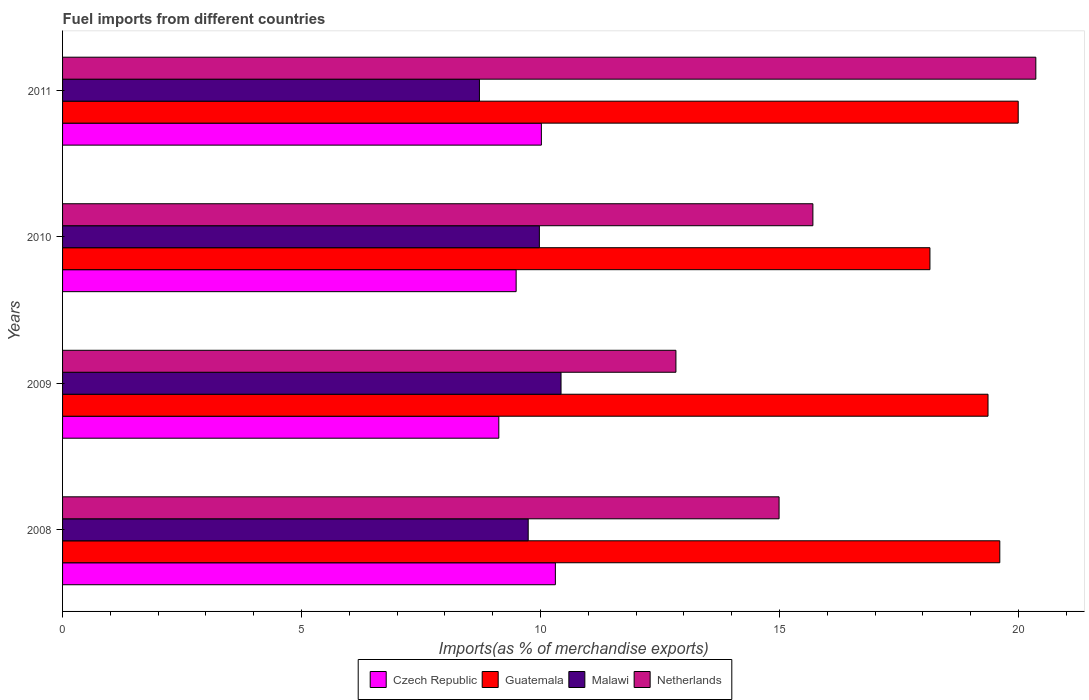How many different coloured bars are there?
Make the answer very short. 4. How many groups of bars are there?
Offer a very short reply. 4. Are the number of bars on each tick of the Y-axis equal?
Make the answer very short. Yes. How many bars are there on the 3rd tick from the bottom?
Provide a succinct answer. 4. In how many cases, is the number of bars for a given year not equal to the number of legend labels?
Your answer should be very brief. 0. What is the percentage of imports to different countries in Guatemala in 2011?
Your answer should be very brief. 19.99. Across all years, what is the maximum percentage of imports to different countries in Netherlands?
Your answer should be very brief. 20.36. Across all years, what is the minimum percentage of imports to different countries in Netherlands?
Give a very brief answer. 12.83. In which year was the percentage of imports to different countries in Netherlands maximum?
Provide a short and direct response. 2011. In which year was the percentage of imports to different countries in Czech Republic minimum?
Make the answer very short. 2009. What is the total percentage of imports to different countries in Guatemala in the graph?
Ensure brevity in your answer.  77.11. What is the difference between the percentage of imports to different countries in Czech Republic in 2008 and that in 2011?
Your answer should be compact. 0.29. What is the difference between the percentage of imports to different countries in Netherlands in 2010 and the percentage of imports to different countries in Czech Republic in 2008?
Provide a succinct answer. 5.39. What is the average percentage of imports to different countries in Czech Republic per year?
Provide a short and direct response. 9.74. In the year 2008, what is the difference between the percentage of imports to different countries in Malawi and percentage of imports to different countries in Guatemala?
Your answer should be compact. -9.87. What is the ratio of the percentage of imports to different countries in Guatemala in 2009 to that in 2010?
Give a very brief answer. 1.07. Is the percentage of imports to different countries in Malawi in 2009 less than that in 2011?
Your response must be concise. No. What is the difference between the highest and the second highest percentage of imports to different countries in Guatemala?
Your answer should be very brief. 0.39. What is the difference between the highest and the lowest percentage of imports to different countries in Guatemala?
Provide a succinct answer. 1.85. In how many years, is the percentage of imports to different countries in Netherlands greater than the average percentage of imports to different countries in Netherlands taken over all years?
Offer a terse response. 1. What does the 1st bar from the top in 2010 represents?
Your answer should be very brief. Netherlands. What does the 1st bar from the bottom in 2008 represents?
Offer a very short reply. Czech Republic. Is it the case that in every year, the sum of the percentage of imports to different countries in Netherlands and percentage of imports to different countries in Malawi is greater than the percentage of imports to different countries in Czech Republic?
Your answer should be compact. Yes. How many bars are there?
Ensure brevity in your answer.  16. What is the difference between two consecutive major ticks on the X-axis?
Ensure brevity in your answer.  5. How many legend labels are there?
Provide a short and direct response. 4. How are the legend labels stacked?
Ensure brevity in your answer.  Horizontal. What is the title of the graph?
Keep it short and to the point. Fuel imports from different countries. What is the label or title of the X-axis?
Provide a succinct answer. Imports(as % of merchandise exports). What is the label or title of the Y-axis?
Make the answer very short. Years. What is the Imports(as % of merchandise exports) of Czech Republic in 2008?
Your answer should be compact. 10.31. What is the Imports(as % of merchandise exports) in Guatemala in 2008?
Provide a succinct answer. 19.61. What is the Imports(as % of merchandise exports) of Malawi in 2008?
Offer a terse response. 9.74. What is the Imports(as % of merchandise exports) in Netherlands in 2008?
Keep it short and to the point. 14.99. What is the Imports(as % of merchandise exports) of Czech Republic in 2009?
Your answer should be compact. 9.13. What is the Imports(as % of merchandise exports) of Guatemala in 2009?
Keep it short and to the point. 19.36. What is the Imports(as % of merchandise exports) of Malawi in 2009?
Give a very brief answer. 10.43. What is the Imports(as % of merchandise exports) of Netherlands in 2009?
Keep it short and to the point. 12.83. What is the Imports(as % of merchandise exports) of Czech Republic in 2010?
Make the answer very short. 9.49. What is the Imports(as % of merchandise exports) of Guatemala in 2010?
Provide a succinct answer. 18.15. What is the Imports(as % of merchandise exports) of Malawi in 2010?
Offer a terse response. 9.98. What is the Imports(as % of merchandise exports) in Netherlands in 2010?
Give a very brief answer. 15.7. What is the Imports(as % of merchandise exports) in Czech Republic in 2011?
Your answer should be very brief. 10.02. What is the Imports(as % of merchandise exports) of Guatemala in 2011?
Offer a very short reply. 19.99. What is the Imports(as % of merchandise exports) in Malawi in 2011?
Provide a succinct answer. 8.72. What is the Imports(as % of merchandise exports) in Netherlands in 2011?
Your answer should be compact. 20.36. Across all years, what is the maximum Imports(as % of merchandise exports) of Czech Republic?
Provide a succinct answer. 10.31. Across all years, what is the maximum Imports(as % of merchandise exports) of Guatemala?
Keep it short and to the point. 19.99. Across all years, what is the maximum Imports(as % of merchandise exports) in Malawi?
Your response must be concise. 10.43. Across all years, what is the maximum Imports(as % of merchandise exports) in Netherlands?
Your answer should be very brief. 20.36. Across all years, what is the minimum Imports(as % of merchandise exports) in Czech Republic?
Make the answer very short. 9.13. Across all years, what is the minimum Imports(as % of merchandise exports) of Guatemala?
Keep it short and to the point. 18.15. Across all years, what is the minimum Imports(as % of merchandise exports) of Malawi?
Your answer should be compact. 8.72. Across all years, what is the minimum Imports(as % of merchandise exports) of Netherlands?
Provide a succinct answer. 12.83. What is the total Imports(as % of merchandise exports) in Czech Republic in the graph?
Make the answer very short. 38.95. What is the total Imports(as % of merchandise exports) of Guatemala in the graph?
Provide a succinct answer. 77.11. What is the total Imports(as % of merchandise exports) in Malawi in the graph?
Offer a terse response. 38.87. What is the total Imports(as % of merchandise exports) of Netherlands in the graph?
Make the answer very short. 63.89. What is the difference between the Imports(as % of merchandise exports) in Czech Republic in 2008 and that in 2009?
Provide a short and direct response. 1.18. What is the difference between the Imports(as % of merchandise exports) of Guatemala in 2008 and that in 2009?
Ensure brevity in your answer.  0.25. What is the difference between the Imports(as % of merchandise exports) in Malawi in 2008 and that in 2009?
Your answer should be compact. -0.69. What is the difference between the Imports(as % of merchandise exports) of Netherlands in 2008 and that in 2009?
Your answer should be compact. 2.16. What is the difference between the Imports(as % of merchandise exports) in Czech Republic in 2008 and that in 2010?
Offer a very short reply. 0.82. What is the difference between the Imports(as % of merchandise exports) in Guatemala in 2008 and that in 2010?
Keep it short and to the point. 1.46. What is the difference between the Imports(as % of merchandise exports) of Malawi in 2008 and that in 2010?
Make the answer very short. -0.23. What is the difference between the Imports(as % of merchandise exports) of Netherlands in 2008 and that in 2010?
Keep it short and to the point. -0.71. What is the difference between the Imports(as % of merchandise exports) in Czech Republic in 2008 and that in 2011?
Give a very brief answer. 0.29. What is the difference between the Imports(as % of merchandise exports) in Guatemala in 2008 and that in 2011?
Give a very brief answer. -0.39. What is the difference between the Imports(as % of merchandise exports) of Malawi in 2008 and that in 2011?
Keep it short and to the point. 1.02. What is the difference between the Imports(as % of merchandise exports) in Netherlands in 2008 and that in 2011?
Make the answer very short. -5.37. What is the difference between the Imports(as % of merchandise exports) of Czech Republic in 2009 and that in 2010?
Your answer should be very brief. -0.36. What is the difference between the Imports(as % of merchandise exports) in Guatemala in 2009 and that in 2010?
Ensure brevity in your answer.  1.21. What is the difference between the Imports(as % of merchandise exports) in Malawi in 2009 and that in 2010?
Keep it short and to the point. 0.45. What is the difference between the Imports(as % of merchandise exports) of Netherlands in 2009 and that in 2010?
Ensure brevity in your answer.  -2.87. What is the difference between the Imports(as % of merchandise exports) in Czech Republic in 2009 and that in 2011?
Provide a short and direct response. -0.89. What is the difference between the Imports(as % of merchandise exports) in Guatemala in 2009 and that in 2011?
Ensure brevity in your answer.  -0.63. What is the difference between the Imports(as % of merchandise exports) of Malawi in 2009 and that in 2011?
Give a very brief answer. 1.71. What is the difference between the Imports(as % of merchandise exports) of Netherlands in 2009 and that in 2011?
Your response must be concise. -7.53. What is the difference between the Imports(as % of merchandise exports) in Czech Republic in 2010 and that in 2011?
Your response must be concise. -0.53. What is the difference between the Imports(as % of merchandise exports) in Guatemala in 2010 and that in 2011?
Give a very brief answer. -1.85. What is the difference between the Imports(as % of merchandise exports) of Malawi in 2010 and that in 2011?
Offer a terse response. 1.25. What is the difference between the Imports(as % of merchandise exports) of Netherlands in 2010 and that in 2011?
Provide a short and direct response. -4.66. What is the difference between the Imports(as % of merchandise exports) of Czech Republic in 2008 and the Imports(as % of merchandise exports) of Guatemala in 2009?
Your answer should be compact. -9.05. What is the difference between the Imports(as % of merchandise exports) in Czech Republic in 2008 and the Imports(as % of merchandise exports) in Malawi in 2009?
Ensure brevity in your answer.  -0.12. What is the difference between the Imports(as % of merchandise exports) in Czech Republic in 2008 and the Imports(as % of merchandise exports) in Netherlands in 2009?
Offer a terse response. -2.52. What is the difference between the Imports(as % of merchandise exports) in Guatemala in 2008 and the Imports(as % of merchandise exports) in Malawi in 2009?
Your answer should be compact. 9.18. What is the difference between the Imports(as % of merchandise exports) of Guatemala in 2008 and the Imports(as % of merchandise exports) of Netherlands in 2009?
Make the answer very short. 6.78. What is the difference between the Imports(as % of merchandise exports) of Malawi in 2008 and the Imports(as % of merchandise exports) of Netherlands in 2009?
Your response must be concise. -3.09. What is the difference between the Imports(as % of merchandise exports) in Czech Republic in 2008 and the Imports(as % of merchandise exports) in Guatemala in 2010?
Provide a short and direct response. -7.84. What is the difference between the Imports(as % of merchandise exports) in Czech Republic in 2008 and the Imports(as % of merchandise exports) in Malawi in 2010?
Your answer should be very brief. 0.33. What is the difference between the Imports(as % of merchandise exports) in Czech Republic in 2008 and the Imports(as % of merchandise exports) in Netherlands in 2010?
Provide a succinct answer. -5.39. What is the difference between the Imports(as % of merchandise exports) in Guatemala in 2008 and the Imports(as % of merchandise exports) in Malawi in 2010?
Give a very brief answer. 9.63. What is the difference between the Imports(as % of merchandise exports) in Guatemala in 2008 and the Imports(as % of merchandise exports) in Netherlands in 2010?
Offer a very short reply. 3.91. What is the difference between the Imports(as % of merchandise exports) of Malawi in 2008 and the Imports(as % of merchandise exports) of Netherlands in 2010?
Provide a short and direct response. -5.96. What is the difference between the Imports(as % of merchandise exports) in Czech Republic in 2008 and the Imports(as % of merchandise exports) in Guatemala in 2011?
Ensure brevity in your answer.  -9.68. What is the difference between the Imports(as % of merchandise exports) in Czech Republic in 2008 and the Imports(as % of merchandise exports) in Malawi in 2011?
Your answer should be very brief. 1.59. What is the difference between the Imports(as % of merchandise exports) in Czech Republic in 2008 and the Imports(as % of merchandise exports) in Netherlands in 2011?
Give a very brief answer. -10.05. What is the difference between the Imports(as % of merchandise exports) of Guatemala in 2008 and the Imports(as % of merchandise exports) of Malawi in 2011?
Keep it short and to the point. 10.89. What is the difference between the Imports(as % of merchandise exports) in Guatemala in 2008 and the Imports(as % of merchandise exports) in Netherlands in 2011?
Make the answer very short. -0.75. What is the difference between the Imports(as % of merchandise exports) of Malawi in 2008 and the Imports(as % of merchandise exports) of Netherlands in 2011?
Your answer should be compact. -10.62. What is the difference between the Imports(as % of merchandise exports) of Czech Republic in 2009 and the Imports(as % of merchandise exports) of Guatemala in 2010?
Your response must be concise. -9.02. What is the difference between the Imports(as % of merchandise exports) in Czech Republic in 2009 and the Imports(as % of merchandise exports) in Malawi in 2010?
Your answer should be very brief. -0.85. What is the difference between the Imports(as % of merchandise exports) of Czech Republic in 2009 and the Imports(as % of merchandise exports) of Netherlands in 2010?
Make the answer very short. -6.57. What is the difference between the Imports(as % of merchandise exports) in Guatemala in 2009 and the Imports(as % of merchandise exports) in Malawi in 2010?
Make the answer very short. 9.39. What is the difference between the Imports(as % of merchandise exports) of Guatemala in 2009 and the Imports(as % of merchandise exports) of Netherlands in 2010?
Offer a very short reply. 3.66. What is the difference between the Imports(as % of merchandise exports) of Malawi in 2009 and the Imports(as % of merchandise exports) of Netherlands in 2010?
Provide a succinct answer. -5.27. What is the difference between the Imports(as % of merchandise exports) of Czech Republic in 2009 and the Imports(as % of merchandise exports) of Guatemala in 2011?
Your answer should be very brief. -10.87. What is the difference between the Imports(as % of merchandise exports) in Czech Republic in 2009 and the Imports(as % of merchandise exports) in Malawi in 2011?
Offer a very short reply. 0.41. What is the difference between the Imports(as % of merchandise exports) in Czech Republic in 2009 and the Imports(as % of merchandise exports) in Netherlands in 2011?
Provide a succinct answer. -11.24. What is the difference between the Imports(as % of merchandise exports) in Guatemala in 2009 and the Imports(as % of merchandise exports) in Malawi in 2011?
Your answer should be compact. 10.64. What is the difference between the Imports(as % of merchandise exports) in Guatemala in 2009 and the Imports(as % of merchandise exports) in Netherlands in 2011?
Your answer should be compact. -1. What is the difference between the Imports(as % of merchandise exports) of Malawi in 2009 and the Imports(as % of merchandise exports) of Netherlands in 2011?
Ensure brevity in your answer.  -9.93. What is the difference between the Imports(as % of merchandise exports) of Czech Republic in 2010 and the Imports(as % of merchandise exports) of Guatemala in 2011?
Your answer should be compact. -10.5. What is the difference between the Imports(as % of merchandise exports) of Czech Republic in 2010 and the Imports(as % of merchandise exports) of Malawi in 2011?
Give a very brief answer. 0.77. What is the difference between the Imports(as % of merchandise exports) of Czech Republic in 2010 and the Imports(as % of merchandise exports) of Netherlands in 2011?
Your response must be concise. -10.87. What is the difference between the Imports(as % of merchandise exports) in Guatemala in 2010 and the Imports(as % of merchandise exports) in Malawi in 2011?
Your answer should be very brief. 9.43. What is the difference between the Imports(as % of merchandise exports) in Guatemala in 2010 and the Imports(as % of merchandise exports) in Netherlands in 2011?
Offer a very short reply. -2.22. What is the difference between the Imports(as % of merchandise exports) of Malawi in 2010 and the Imports(as % of merchandise exports) of Netherlands in 2011?
Provide a succinct answer. -10.39. What is the average Imports(as % of merchandise exports) of Czech Republic per year?
Give a very brief answer. 9.74. What is the average Imports(as % of merchandise exports) in Guatemala per year?
Make the answer very short. 19.28. What is the average Imports(as % of merchandise exports) of Malawi per year?
Your answer should be compact. 9.72. What is the average Imports(as % of merchandise exports) in Netherlands per year?
Offer a very short reply. 15.97. In the year 2008, what is the difference between the Imports(as % of merchandise exports) of Czech Republic and Imports(as % of merchandise exports) of Guatemala?
Your response must be concise. -9.3. In the year 2008, what is the difference between the Imports(as % of merchandise exports) in Czech Republic and Imports(as % of merchandise exports) in Malawi?
Keep it short and to the point. 0.57. In the year 2008, what is the difference between the Imports(as % of merchandise exports) of Czech Republic and Imports(as % of merchandise exports) of Netherlands?
Provide a succinct answer. -4.68. In the year 2008, what is the difference between the Imports(as % of merchandise exports) in Guatemala and Imports(as % of merchandise exports) in Malawi?
Your answer should be compact. 9.87. In the year 2008, what is the difference between the Imports(as % of merchandise exports) of Guatemala and Imports(as % of merchandise exports) of Netherlands?
Your response must be concise. 4.62. In the year 2008, what is the difference between the Imports(as % of merchandise exports) of Malawi and Imports(as % of merchandise exports) of Netherlands?
Your answer should be compact. -5.25. In the year 2009, what is the difference between the Imports(as % of merchandise exports) of Czech Republic and Imports(as % of merchandise exports) of Guatemala?
Your response must be concise. -10.23. In the year 2009, what is the difference between the Imports(as % of merchandise exports) of Czech Republic and Imports(as % of merchandise exports) of Malawi?
Your answer should be very brief. -1.3. In the year 2009, what is the difference between the Imports(as % of merchandise exports) of Czech Republic and Imports(as % of merchandise exports) of Netherlands?
Provide a short and direct response. -3.71. In the year 2009, what is the difference between the Imports(as % of merchandise exports) in Guatemala and Imports(as % of merchandise exports) in Malawi?
Ensure brevity in your answer.  8.93. In the year 2009, what is the difference between the Imports(as % of merchandise exports) of Guatemala and Imports(as % of merchandise exports) of Netherlands?
Make the answer very short. 6.53. In the year 2009, what is the difference between the Imports(as % of merchandise exports) of Malawi and Imports(as % of merchandise exports) of Netherlands?
Provide a short and direct response. -2.4. In the year 2010, what is the difference between the Imports(as % of merchandise exports) in Czech Republic and Imports(as % of merchandise exports) in Guatemala?
Make the answer very short. -8.66. In the year 2010, what is the difference between the Imports(as % of merchandise exports) of Czech Republic and Imports(as % of merchandise exports) of Malawi?
Make the answer very short. -0.49. In the year 2010, what is the difference between the Imports(as % of merchandise exports) of Czech Republic and Imports(as % of merchandise exports) of Netherlands?
Make the answer very short. -6.21. In the year 2010, what is the difference between the Imports(as % of merchandise exports) in Guatemala and Imports(as % of merchandise exports) in Malawi?
Offer a very short reply. 8.17. In the year 2010, what is the difference between the Imports(as % of merchandise exports) of Guatemala and Imports(as % of merchandise exports) of Netherlands?
Give a very brief answer. 2.45. In the year 2010, what is the difference between the Imports(as % of merchandise exports) in Malawi and Imports(as % of merchandise exports) in Netherlands?
Make the answer very short. -5.72. In the year 2011, what is the difference between the Imports(as % of merchandise exports) of Czech Republic and Imports(as % of merchandise exports) of Guatemala?
Offer a terse response. -9.98. In the year 2011, what is the difference between the Imports(as % of merchandise exports) in Czech Republic and Imports(as % of merchandise exports) in Malawi?
Provide a succinct answer. 1.3. In the year 2011, what is the difference between the Imports(as % of merchandise exports) of Czech Republic and Imports(as % of merchandise exports) of Netherlands?
Keep it short and to the point. -10.35. In the year 2011, what is the difference between the Imports(as % of merchandise exports) in Guatemala and Imports(as % of merchandise exports) in Malawi?
Your answer should be very brief. 11.27. In the year 2011, what is the difference between the Imports(as % of merchandise exports) of Guatemala and Imports(as % of merchandise exports) of Netherlands?
Offer a terse response. -0.37. In the year 2011, what is the difference between the Imports(as % of merchandise exports) in Malawi and Imports(as % of merchandise exports) in Netherlands?
Ensure brevity in your answer.  -11.64. What is the ratio of the Imports(as % of merchandise exports) in Czech Republic in 2008 to that in 2009?
Offer a terse response. 1.13. What is the ratio of the Imports(as % of merchandise exports) in Guatemala in 2008 to that in 2009?
Make the answer very short. 1.01. What is the ratio of the Imports(as % of merchandise exports) in Malawi in 2008 to that in 2009?
Your response must be concise. 0.93. What is the ratio of the Imports(as % of merchandise exports) of Netherlands in 2008 to that in 2009?
Provide a succinct answer. 1.17. What is the ratio of the Imports(as % of merchandise exports) of Czech Republic in 2008 to that in 2010?
Offer a terse response. 1.09. What is the ratio of the Imports(as % of merchandise exports) of Guatemala in 2008 to that in 2010?
Your answer should be compact. 1.08. What is the ratio of the Imports(as % of merchandise exports) of Malawi in 2008 to that in 2010?
Provide a succinct answer. 0.98. What is the ratio of the Imports(as % of merchandise exports) in Netherlands in 2008 to that in 2010?
Make the answer very short. 0.95. What is the ratio of the Imports(as % of merchandise exports) of Czech Republic in 2008 to that in 2011?
Offer a terse response. 1.03. What is the ratio of the Imports(as % of merchandise exports) in Guatemala in 2008 to that in 2011?
Your answer should be compact. 0.98. What is the ratio of the Imports(as % of merchandise exports) of Malawi in 2008 to that in 2011?
Provide a succinct answer. 1.12. What is the ratio of the Imports(as % of merchandise exports) in Netherlands in 2008 to that in 2011?
Provide a short and direct response. 0.74. What is the ratio of the Imports(as % of merchandise exports) in Czech Republic in 2009 to that in 2010?
Your answer should be very brief. 0.96. What is the ratio of the Imports(as % of merchandise exports) in Guatemala in 2009 to that in 2010?
Your response must be concise. 1.07. What is the ratio of the Imports(as % of merchandise exports) of Malawi in 2009 to that in 2010?
Offer a very short reply. 1.05. What is the ratio of the Imports(as % of merchandise exports) of Netherlands in 2009 to that in 2010?
Make the answer very short. 0.82. What is the ratio of the Imports(as % of merchandise exports) in Czech Republic in 2009 to that in 2011?
Your answer should be compact. 0.91. What is the ratio of the Imports(as % of merchandise exports) of Guatemala in 2009 to that in 2011?
Offer a terse response. 0.97. What is the ratio of the Imports(as % of merchandise exports) in Malawi in 2009 to that in 2011?
Your response must be concise. 1.2. What is the ratio of the Imports(as % of merchandise exports) of Netherlands in 2009 to that in 2011?
Your response must be concise. 0.63. What is the ratio of the Imports(as % of merchandise exports) in Czech Republic in 2010 to that in 2011?
Provide a succinct answer. 0.95. What is the ratio of the Imports(as % of merchandise exports) in Guatemala in 2010 to that in 2011?
Provide a short and direct response. 0.91. What is the ratio of the Imports(as % of merchandise exports) in Malawi in 2010 to that in 2011?
Provide a succinct answer. 1.14. What is the ratio of the Imports(as % of merchandise exports) in Netherlands in 2010 to that in 2011?
Provide a short and direct response. 0.77. What is the difference between the highest and the second highest Imports(as % of merchandise exports) of Czech Republic?
Provide a succinct answer. 0.29. What is the difference between the highest and the second highest Imports(as % of merchandise exports) of Guatemala?
Provide a succinct answer. 0.39. What is the difference between the highest and the second highest Imports(as % of merchandise exports) of Malawi?
Offer a very short reply. 0.45. What is the difference between the highest and the second highest Imports(as % of merchandise exports) of Netherlands?
Give a very brief answer. 4.66. What is the difference between the highest and the lowest Imports(as % of merchandise exports) of Czech Republic?
Offer a very short reply. 1.18. What is the difference between the highest and the lowest Imports(as % of merchandise exports) in Guatemala?
Give a very brief answer. 1.85. What is the difference between the highest and the lowest Imports(as % of merchandise exports) of Malawi?
Offer a very short reply. 1.71. What is the difference between the highest and the lowest Imports(as % of merchandise exports) in Netherlands?
Give a very brief answer. 7.53. 